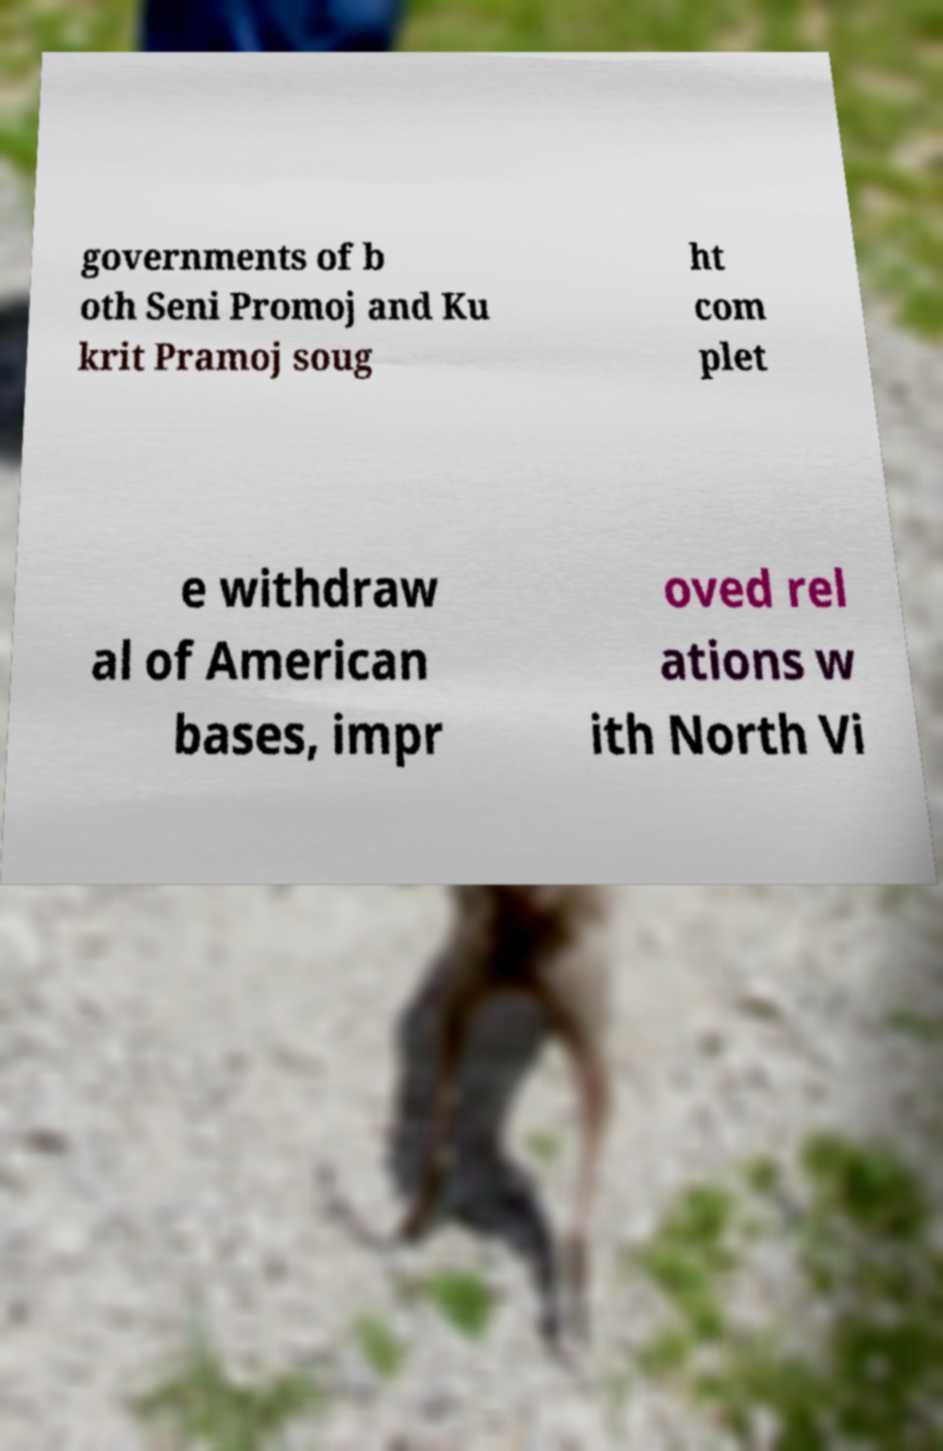There's text embedded in this image that I need extracted. Can you transcribe it verbatim? governments of b oth Seni Promoj and Ku krit Pramoj soug ht com plet e withdraw al of American bases, impr oved rel ations w ith North Vi 